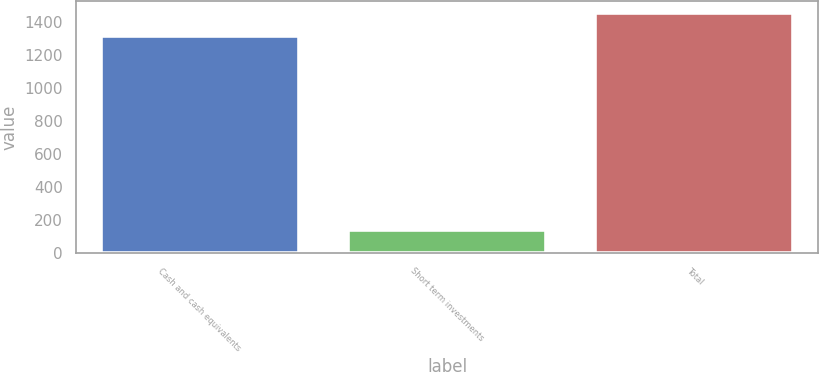<chart> <loc_0><loc_0><loc_500><loc_500><bar_chart><fcel>Cash and cash equivalents<fcel>Short term investments<fcel>Total<nl><fcel>1311<fcel>144<fcel>1455<nl></chart> 